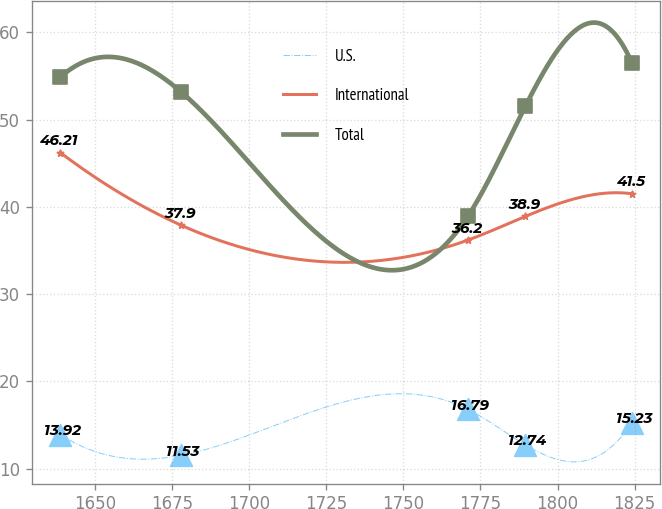Convert chart to OTSL. <chart><loc_0><loc_0><loc_500><loc_500><line_chart><ecel><fcel>U.S.<fcel>International<fcel>Total<nl><fcel>1638.64<fcel>13.92<fcel>46.21<fcel>54.85<nl><fcel>1677.8<fcel>11.53<fcel>37.9<fcel>53.18<nl><fcel>1771<fcel>16.79<fcel>36.2<fcel>38.96<nl><fcel>1789.55<fcel>12.74<fcel>38.9<fcel>51.51<nl><fcel>1824.09<fcel>15.23<fcel>41.5<fcel>56.52<nl></chart> 